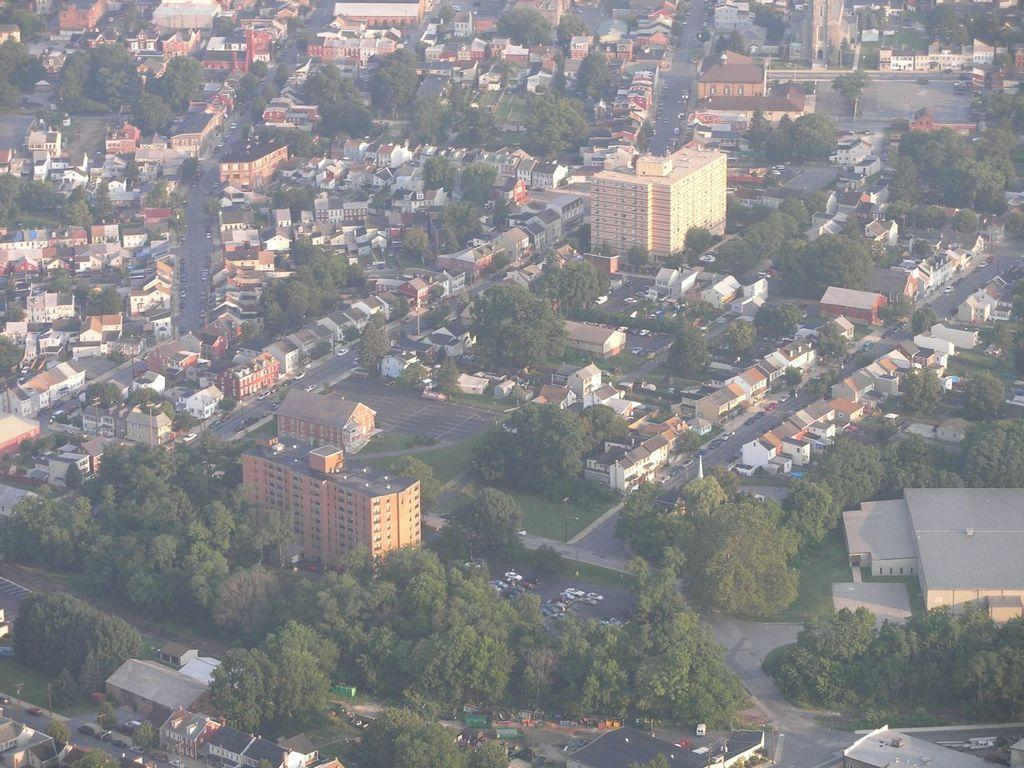What type of view is provided in the image? The image is a top view. What structures can be seen in the image? There are buildings in the image. What type of natural elements are present in the image? There are trees in the image. What type of man-made structures are visible in the image? There are roads in the image. What is happening on the roads in the image? Vehicles are moving on the roads in the image. What type of error can be seen in the image? There is no error present in the image. What type of event is taking place in the image? The image does not depict a specific event; it shows a general view of buildings, trees, roads, and moving vehicles. 